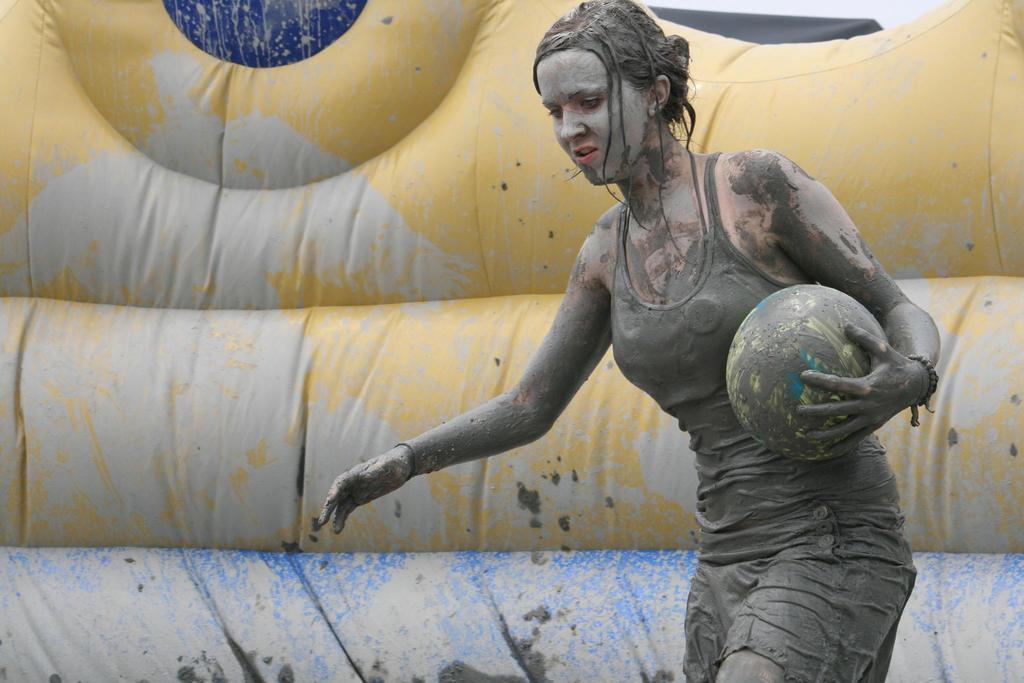How would you summarize this image in a sentence or two? In this image there is a woman who is holding the ball. There is full of mud to her dress and her face. In the background there is a gas balloon. 